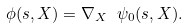<formula> <loc_0><loc_0><loc_500><loc_500>\phi ( s , X ) = \nabla _ { X } \ \psi _ { 0 } ( s , X ) .</formula> 